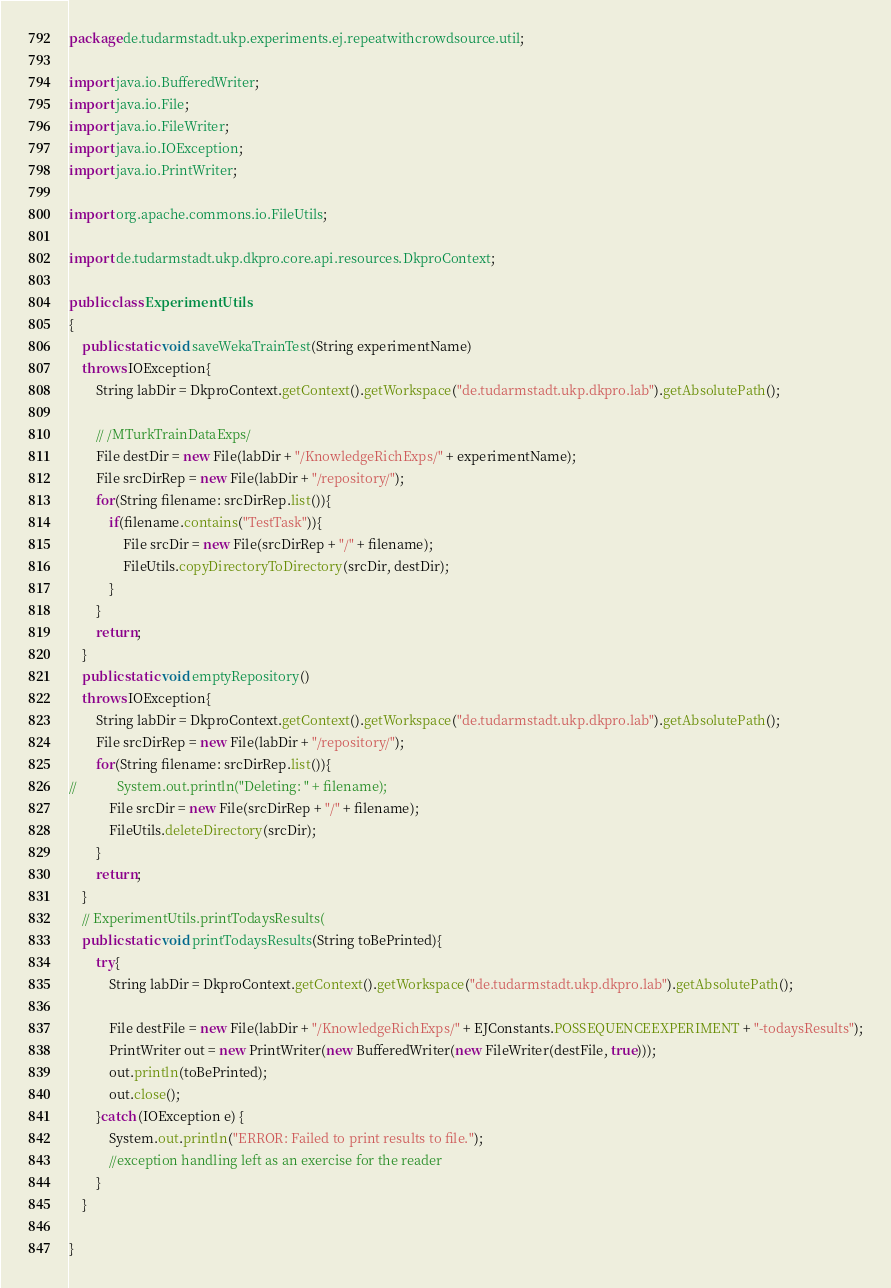Convert code to text. <code><loc_0><loc_0><loc_500><loc_500><_Java_>package de.tudarmstadt.ukp.experiments.ej.repeatwithcrowdsource.util;

import java.io.BufferedWriter;
import java.io.File;
import java.io.FileWriter;
import java.io.IOException;
import java.io.PrintWriter;

import org.apache.commons.io.FileUtils;

import de.tudarmstadt.ukp.dkpro.core.api.resources.DkproContext;

public class ExperimentUtils
{
    public static void saveWekaTrainTest(String experimentName)
    throws IOException{
        String labDir = DkproContext.getContext().getWorkspace("de.tudarmstadt.ukp.dkpro.lab").getAbsolutePath();
        
        // /MTurkTrainDataExps/
        File destDir = new File(labDir + "/KnowledgeRichExps/" + experimentName);
        File srcDirRep = new File(labDir + "/repository/");
        for(String filename: srcDirRep.list()){
            if(filename.contains("TestTask")){
                File srcDir = new File(srcDirRep + "/" + filename);
                FileUtils.copyDirectoryToDirectory(srcDir, destDir);
            }
        }
        return;
    }
    public static void emptyRepository()
    throws IOException{
        String labDir = DkproContext.getContext().getWorkspace("de.tudarmstadt.ukp.dkpro.lab").getAbsolutePath();
        File srcDirRep = new File(labDir + "/repository/");
        for(String filename: srcDirRep.list()){
//            System.out.println("Deleting: " + filename);
            File srcDir = new File(srcDirRep + "/" + filename);
            FileUtils.deleteDirectory(srcDir);
        }
        return;
    }
    // ExperimentUtils.printTodaysResults(
    public static void printTodaysResults(String toBePrinted){
    	try{
    		String labDir = DkproContext.getContext().getWorkspace("de.tudarmstadt.ukp.dkpro.lab").getAbsolutePath();
            
            File destFile = new File(labDir + "/KnowledgeRichExps/" + EJConstants.POSSEQUENCEEXPERIMENT + "-todaysResults");
            PrintWriter out = new PrintWriter(new BufferedWriter(new FileWriter(destFile, true)));
            out.println(toBePrinted);
            out.close();
        }catch (IOException e) {
        	System.out.println("ERROR: Failed to print results to file.");
            //exception handling left as an exercise for the reader
        }
    }

}
</code> 